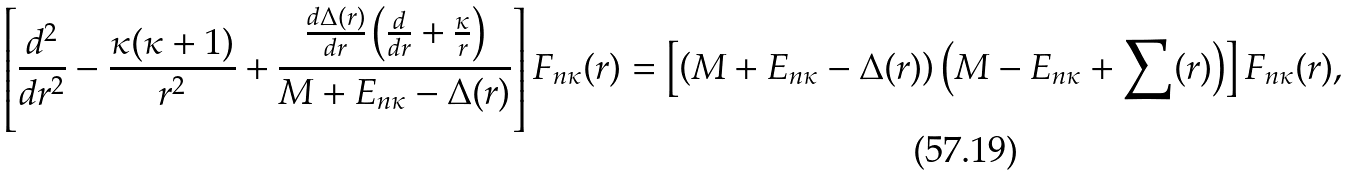<formula> <loc_0><loc_0><loc_500><loc_500>\left [ \frac { d ^ { 2 } } { d r ^ { 2 } } - \frac { \kappa ( \kappa + 1 ) } { r ^ { 2 } } + \frac { \frac { d \Delta ( r ) } { d r } \left ( \frac { d } { d r } + \frac { \kappa } { r } \right ) } { M + E _ { n \kappa } - \Delta ( r ) } \right ] F _ { n \kappa } ( r ) = \left [ \left ( M + E _ { n \kappa } - \Delta ( r ) \right ) \left ( M - E _ { n \kappa } + \sum ( r ) \right ) \right ] F _ { n \kappa } ( r ) ,</formula> 